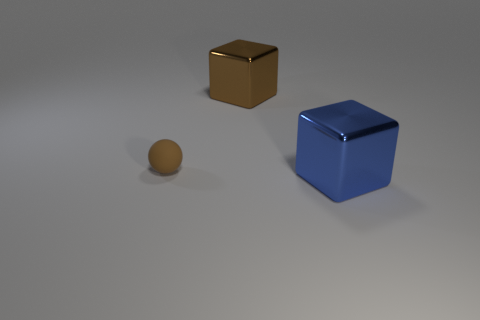The large brown thing that is the same material as the blue cube is what shape?
Provide a short and direct response. Cube. Is there any other thing that is the same shape as the tiny thing?
Offer a very short reply. No. What color is the large block that is in front of the thing that is left of the shiny object that is behind the big blue metal object?
Your response must be concise. Blue. Is the number of small objects that are behind the brown matte sphere less than the number of big brown blocks that are to the right of the large blue block?
Offer a terse response. No. Is the brown rubber object the same shape as the large brown metal object?
Give a very brief answer. No. What number of gray shiny spheres are the same size as the blue metal cube?
Your answer should be compact. 0. Is the number of large blue metal cubes that are on the left side of the tiny brown rubber sphere less than the number of small brown things?
Provide a short and direct response. Yes. There is a metal object that is right of the big object on the left side of the blue shiny object; how big is it?
Make the answer very short. Large. How many objects are large objects or cyan rubber blocks?
Keep it short and to the point. 2. Are there any spheres that have the same color as the matte object?
Keep it short and to the point. No. 